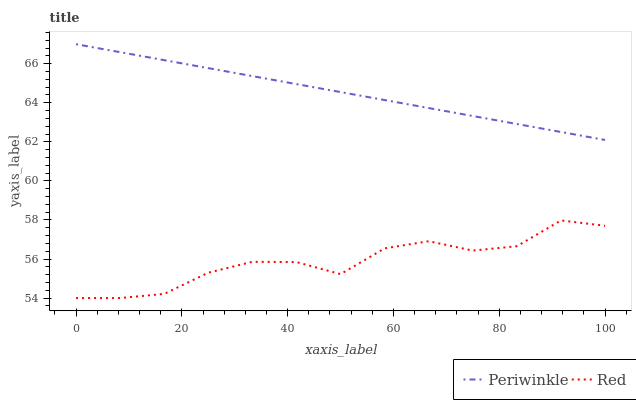Does Red have the minimum area under the curve?
Answer yes or no. Yes. Does Periwinkle have the maximum area under the curve?
Answer yes or no. Yes. Does Red have the maximum area under the curve?
Answer yes or no. No. Is Periwinkle the smoothest?
Answer yes or no. Yes. Is Red the roughest?
Answer yes or no. Yes. Is Red the smoothest?
Answer yes or no. No. Does Red have the lowest value?
Answer yes or no. Yes. Does Periwinkle have the highest value?
Answer yes or no. Yes. Does Red have the highest value?
Answer yes or no. No. Is Red less than Periwinkle?
Answer yes or no. Yes. Is Periwinkle greater than Red?
Answer yes or no. Yes. Does Red intersect Periwinkle?
Answer yes or no. No. 